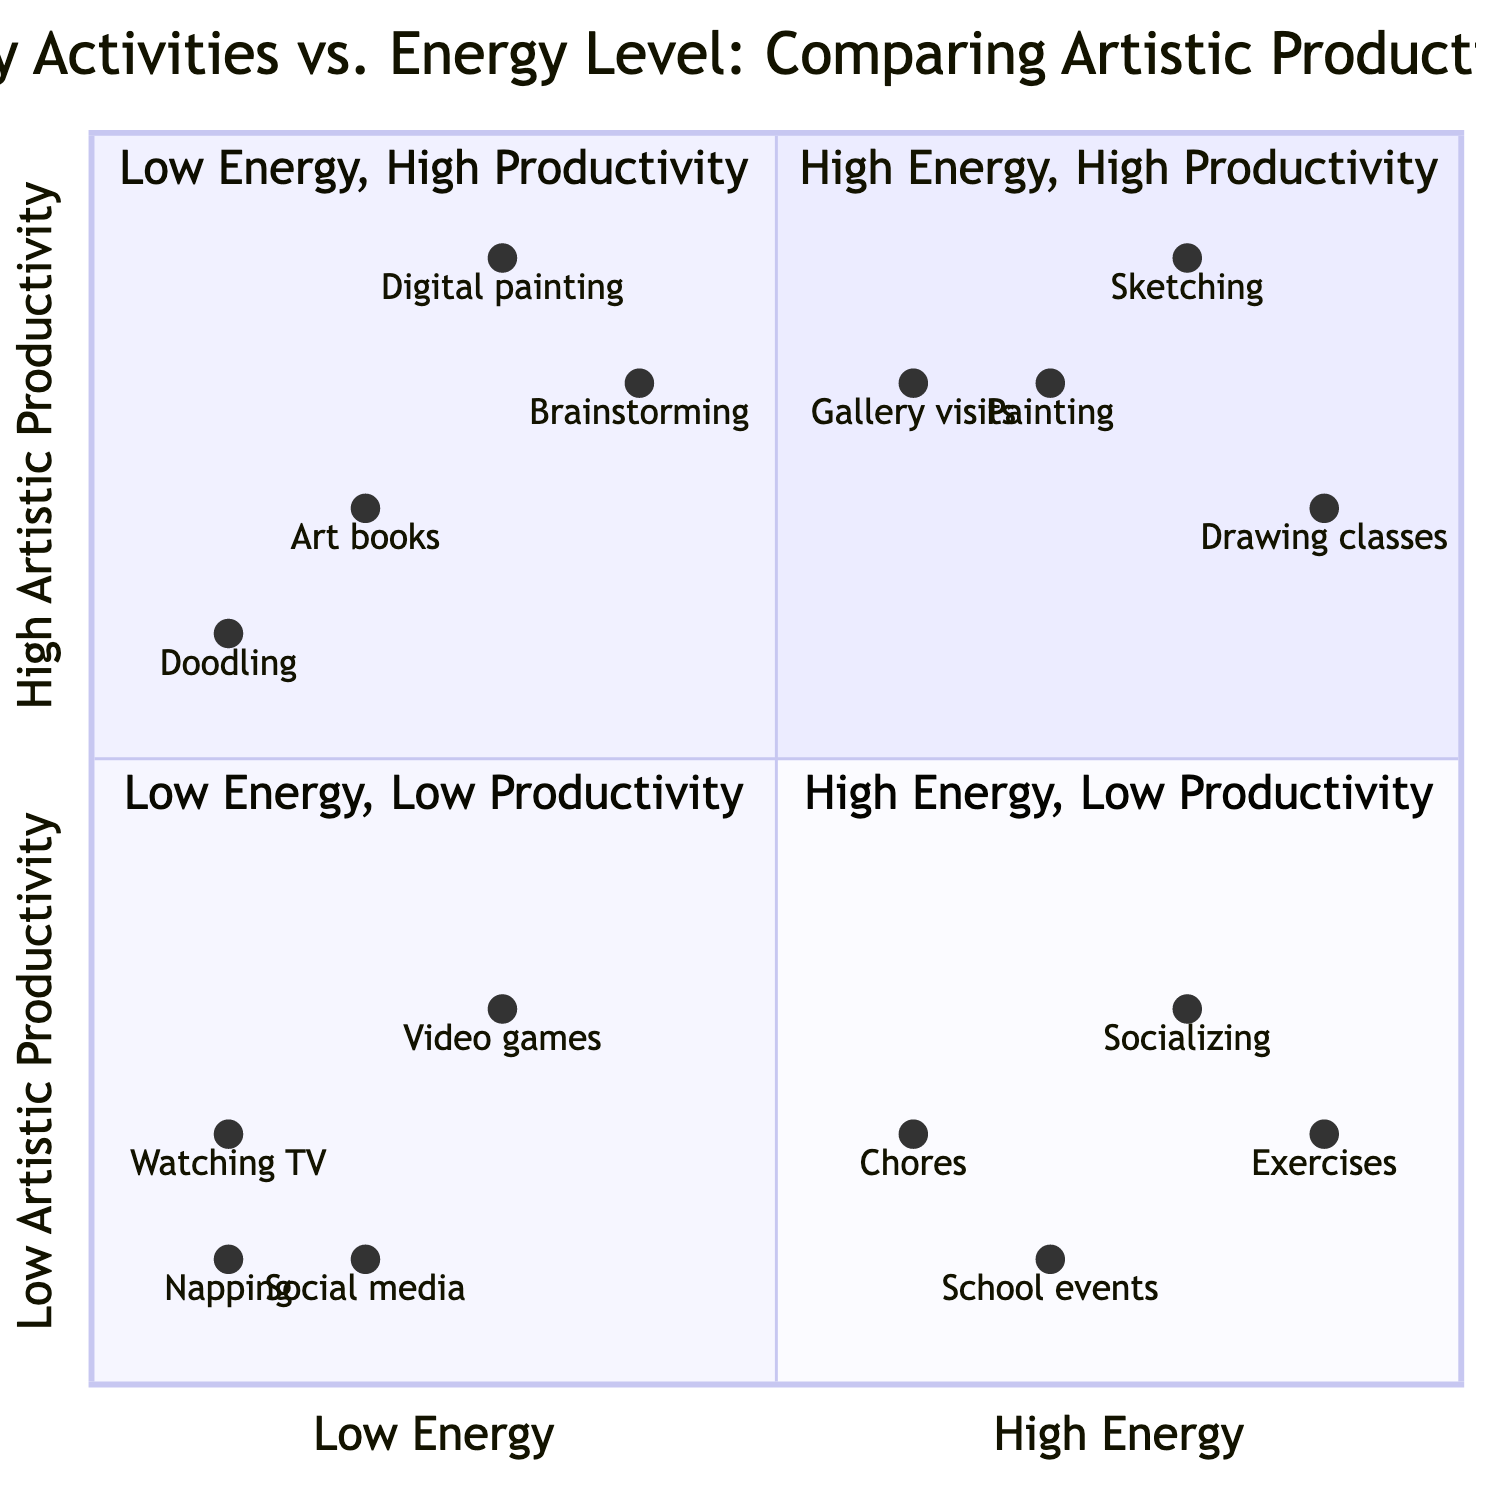What activities fall under High Energy, High Artistic Productivity? According to the quadrant chart, the activities listed in the "High Energy, High Artistic Productivity" quadrant include "Sketching at dawn," "Painting after a morning run," "Drawing classes," and "Doing art during exhibitions or gallery visits." These activities are prioritized when energy and productivity are at their peak.
Answer: Sketching at dawn, Painting after a morning run, Drawing classes, Doing art during exhibitions or gallery visits Which activity has the lowest artistic productivity in the Low Energy, Low Artistic Productivity quadrant? The activities in the "Low Energy, Low Artistic Productivity" quadrant include "Passive social media scrolling," "Watching TV or movies," "Playing video games," and "Taking a nap." Among these, "Taking a nap" is a common activity typically associated with low productivity, suggesting it has the lowest artistic productivity of the listed activities.
Answer: Taking a nap How many activities are categorized under High Energy, Low Artistic Productivity? In the "High Energy, Low Artistic Productivity" quadrant, there are four activities mentioned: "Socializing with friends," "Physical exercises," "Attending school sports events," and "Household chores." Thus, the total number of activities is simply counted.
Answer: Four Which quadrant contains late-night digital painting sessions? The activity "Late-night digital painting sessions" is found in the "Low Energy, High Artistic Productivity" quadrant. This means that despite the low energy during such hours, the artistic output remains high. The correlation indicates that being less energetic can lead to productive periods for specific artistic tasks.
Answer: Low Energy, High Artistic Productivity What activity shows the highest energy level in the Low Energy, High Artistic Productivity quadrant? Looking at the chart, activities in the "Low Energy, High Artistic Productivity" quadrant should be assessed based on their energy-level values. The "Late-night digital painting sessions" is given coordinates where energy is notably low (0.3) while still achieving high productivity (0.9). Hence, it fits the criteria for maximizing productivity.
Answer: Late-night digital painting sessions What is the relationship between socializing with friends and artistic productivity? In the "High Energy, Low Artistic Productivity" quadrant, "Socializing with friends" has a high energy level (0.8) but its artistic productivity is low (0.3). Therefore, the relationship suggests that while socializing requires significant energy, it does not contribute positively to artistic productivity.
Answer: High energy, low productivity Which activity has the highest productivity in the Low Energy, Low Artistic Productivity quadrant? The activities in the "Low Energy, Low Artistic Productivity" quadrant include "Passive social media scrolling," "Watching TV or movies," "Playing video games," and "Taking a nap." Based on their productivity scores, it appears that "Playing video games" holds the highest productivity value (0.3) within this low output group.
Answer: Playing video games What can be inferred about attending school sports events in terms of productivity? "Attending school sports events" is classified in the "High Energy, Low Artistic Productivity" quadrant with corresponding coordinates indicating high energy (0.7) but low productivity (0.1). This implies that while the activity requires significant energy, it does not facilitate artistic output effectively. Hence, it is not a productive use of energy for art.
Answer: Not productive for art 